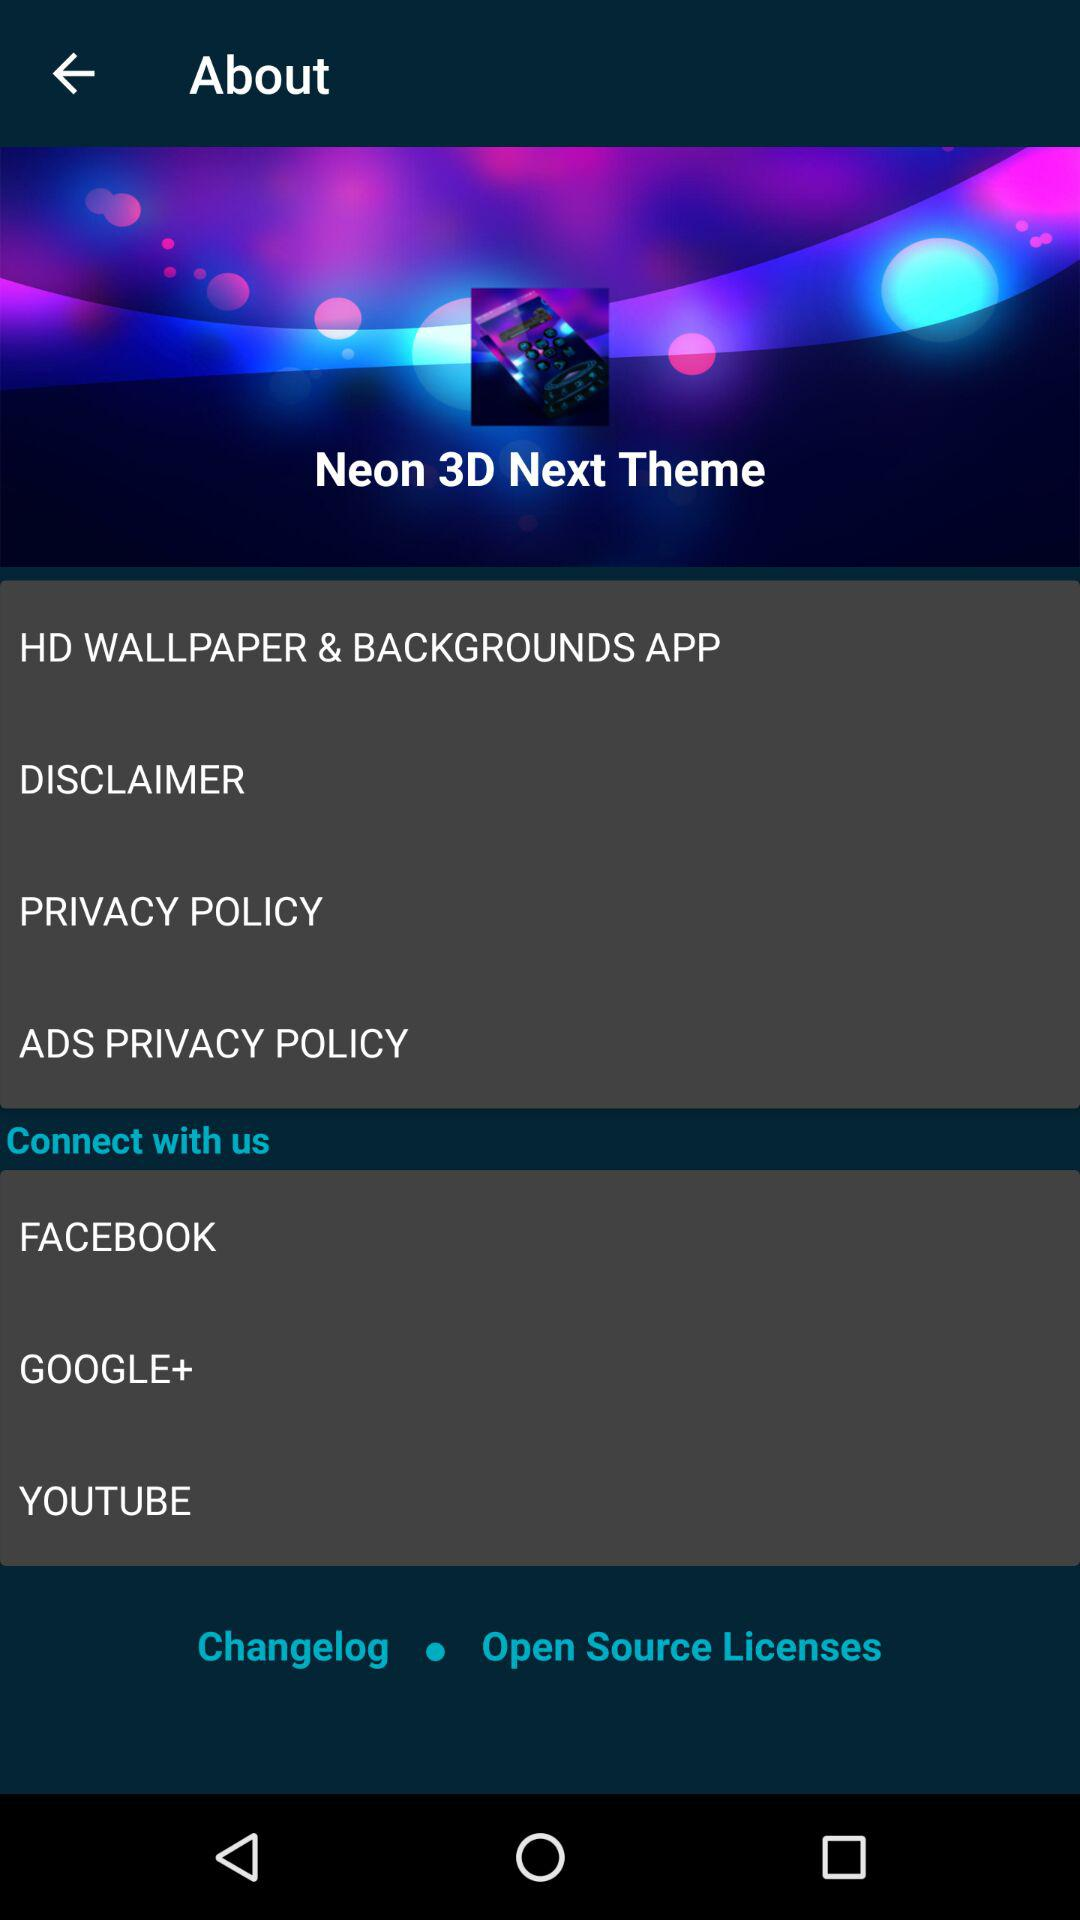What is the name of the application? The name of the application is "Neon 3D Next Theme". 